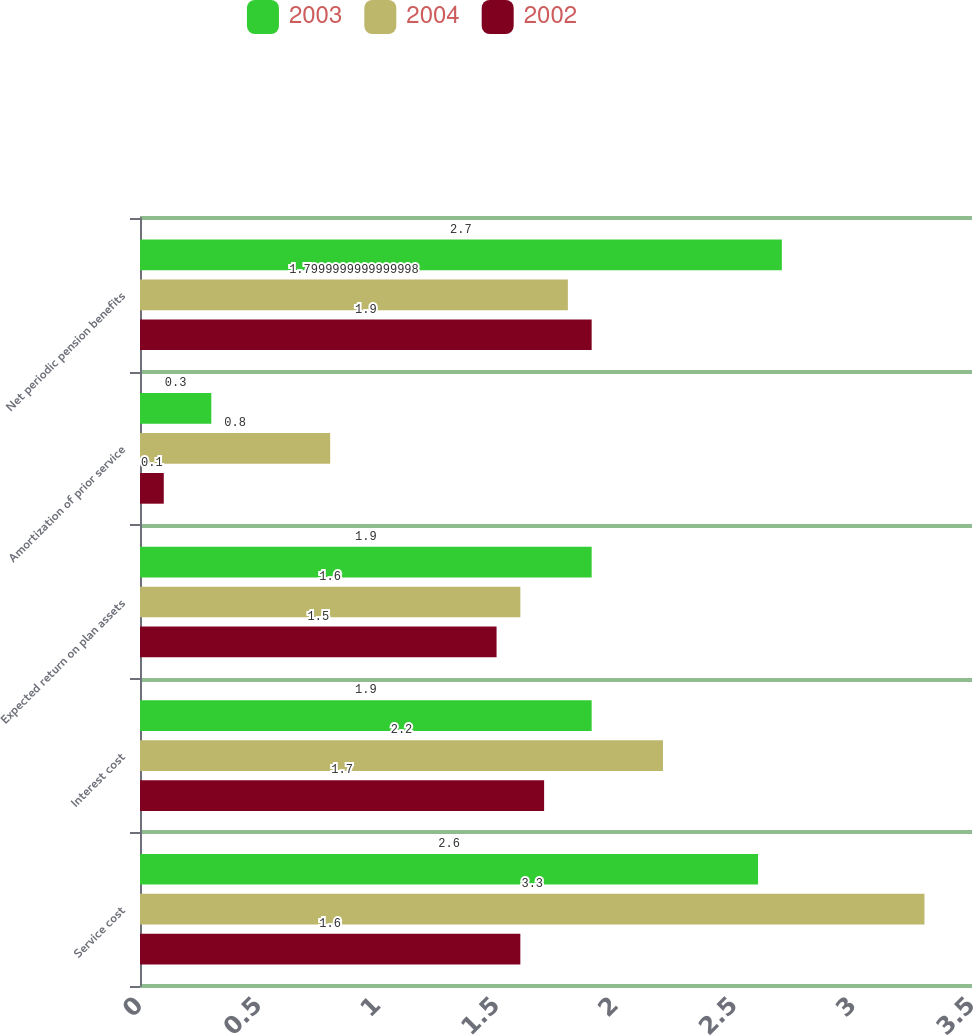Convert chart to OTSL. <chart><loc_0><loc_0><loc_500><loc_500><stacked_bar_chart><ecel><fcel>Service cost<fcel>Interest cost<fcel>Expected return on plan assets<fcel>Amortization of prior service<fcel>Net periodic pension benefits<nl><fcel>2003<fcel>2.6<fcel>1.9<fcel>1.9<fcel>0.3<fcel>2.7<nl><fcel>2004<fcel>3.3<fcel>2.2<fcel>1.6<fcel>0.8<fcel>1.8<nl><fcel>2002<fcel>1.6<fcel>1.7<fcel>1.5<fcel>0.1<fcel>1.9<nl></chart> 